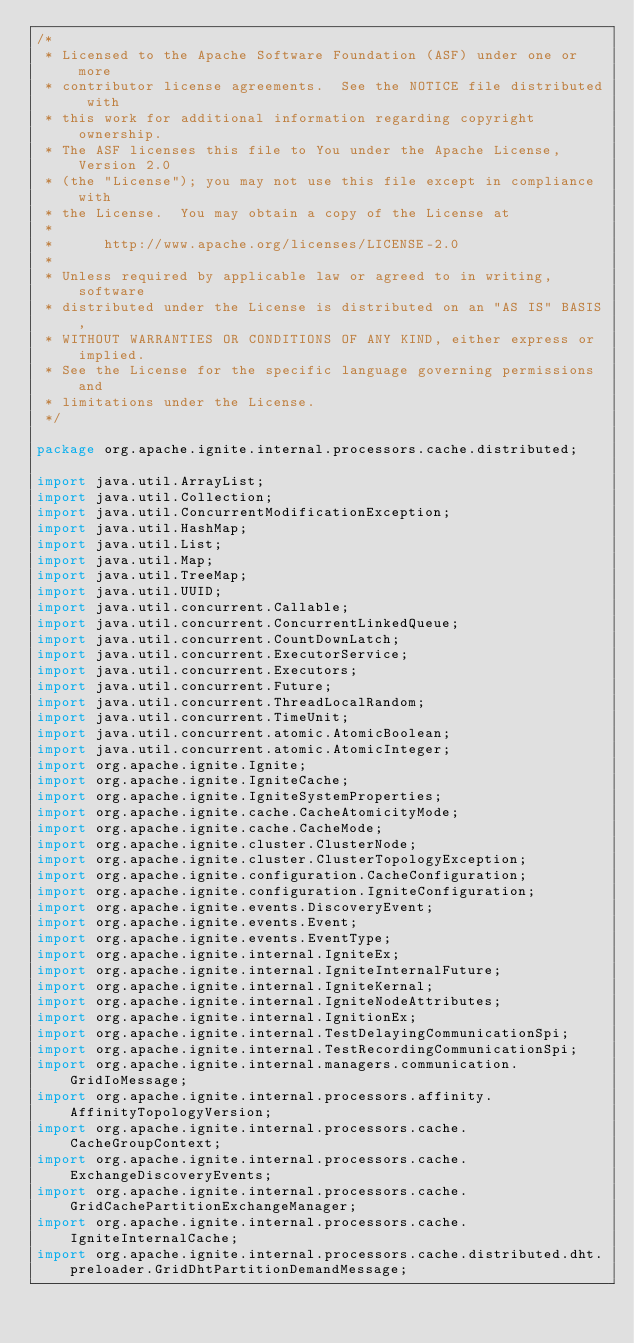Convert code to text. <code><loc_0><loc_0><loc_500><loc_500><_Java_>/*
 * Licensed to the Apache Software Foundation (ASF) under one or more
 * contributor license agreements.  See the NOTICE file distributed with
 * this work for additional information regarding copyright ownership.
 * The ASF licenses this file to You under the Apache License, Version 2.0
 * (the "License"); you may not use this file except in compliance with
 * the License.  You may obtain a copy of the License at
 *
 *      http://www.apache.org/licenses/LICENSE-2.0
 *
 * Unless required by applicable law or agreed to in writing, software
 * distributed under the License is distributed on an "AS IS" BASIS,
 * WITHOUT WARRANTIES OR CONDITIONS OF ANY KIND, either express or implied.
 * See the License for the specific language governing permissions and
 * limitations under the License.
 */

package org.apache.ignite.internal.processors.cache.distributed;

import java.util.ArrayList;
import java.util.Collection;
import java.util.ConcurrentModificationException;
import java.util.HashMap;
import java.util.List;
import java.util.Map;
import java.util.TreeMap;
import java.util.UUID;
import java.util.concurrent.Callable;
import java.util.concurrent.ConcurrentLinkedQueue;
import java.util.concurrent.CountDownLatch;
import java.util.concurrent.ExecutorService;
import java.util.concurrent.Executors;
import java.util.concurrent.Future;
import java.util.concurrent.ThreadLocalRandom;
import java.util.concurrent.TimeUnit;
import java.util.concurrent.atomic.AtomicBoolean;
import java.util.concurrent.atomic.AtomicInteger;
import org.apache.ignite.Ignite;
import org.apache.ignite.IgniteCache;
import org.apache.ignite.IgniteSystemProperties;
import org.apache.ignite.cache.CacheAtomicityMode;
import org.apache.ignite.cache.CacheMode;
import org.apache.ignite.cluster.ClusterNode;
import org.apache.ignite.cluster.ClusterTopologyException;
import org.apache.ignite.configuration.CacheConfiguration;
import org.apache.ignite.configuration.IgniteConfiguration;
import org.apache.ignite.events.DiscoveryEvent;
import org.apache.ignite.events.Event;
import org.apache.ignite.events.EventType;
import org.apache.ignite.internal.IgniteEx;
import org.apache.ignite.internal.IgniteInternalFuture;
import org.apache.ignite.internal.IgniteKernal;
import org.apache.ignite.internal.IgniteNodeAttributes;
import org.apache.ignite.internal.IgnitionEx;
import org.apache.ignite.internal.TestDelayingCommunicationSpi;
import org.apache.ignite.internal.TestRecordingCommunicationSpi;
import org.apache.ignite.internal.managers.communication.GridIoMessage;
import org.apache.ignite.internal.processors.affinity.AffinityTopologyVersion;
import org.apache.ignite.internal.processors.cache.CacheGroupContext;
import org.apache.ignite.internal.processors.cache.ExchangeDiscoveryEvents;
import org.apache.ignite.internal.processors.cache.GridCachePartitionExchangeManager;
import org.apache.ignite.internal.processors.cache.IgniteInternalCache;
import org.apache.ignite.internal.processors.cache.distributed.dht.preloader.GridDhtPartitionDemandMessage;</code> 